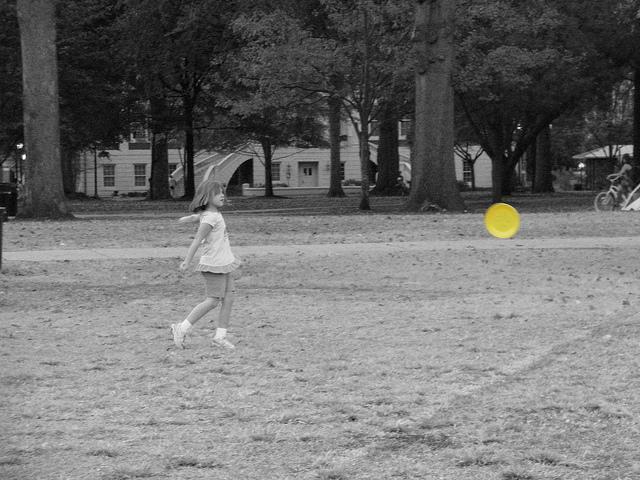How many balls?
Give a very brief answer. 0. How many boats are in front of the church?
Give a very brief answer. 0. 